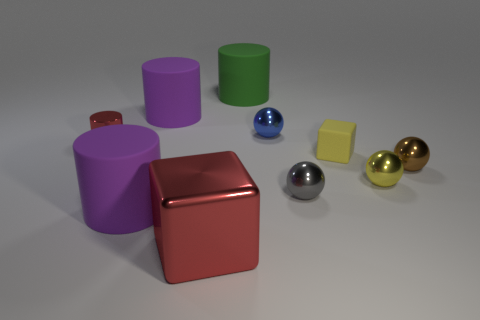Subtract 1 spheres. How many spheres are left? 3 Subtract all purple spheres. Subtract all red cubes. How many spheres are left? 4 Subtract all cylinders. How many objects are left? 6 Subtract 0 gray blocks. How many objects are left? 10 Subtract all matte cylinders. Subtract all cylinders. How many objects are left? 3 Add 5 small gray metallic balls. How many small gray metallic balls are left? 6 Add 7 large green things. How many large green things exist? 8 